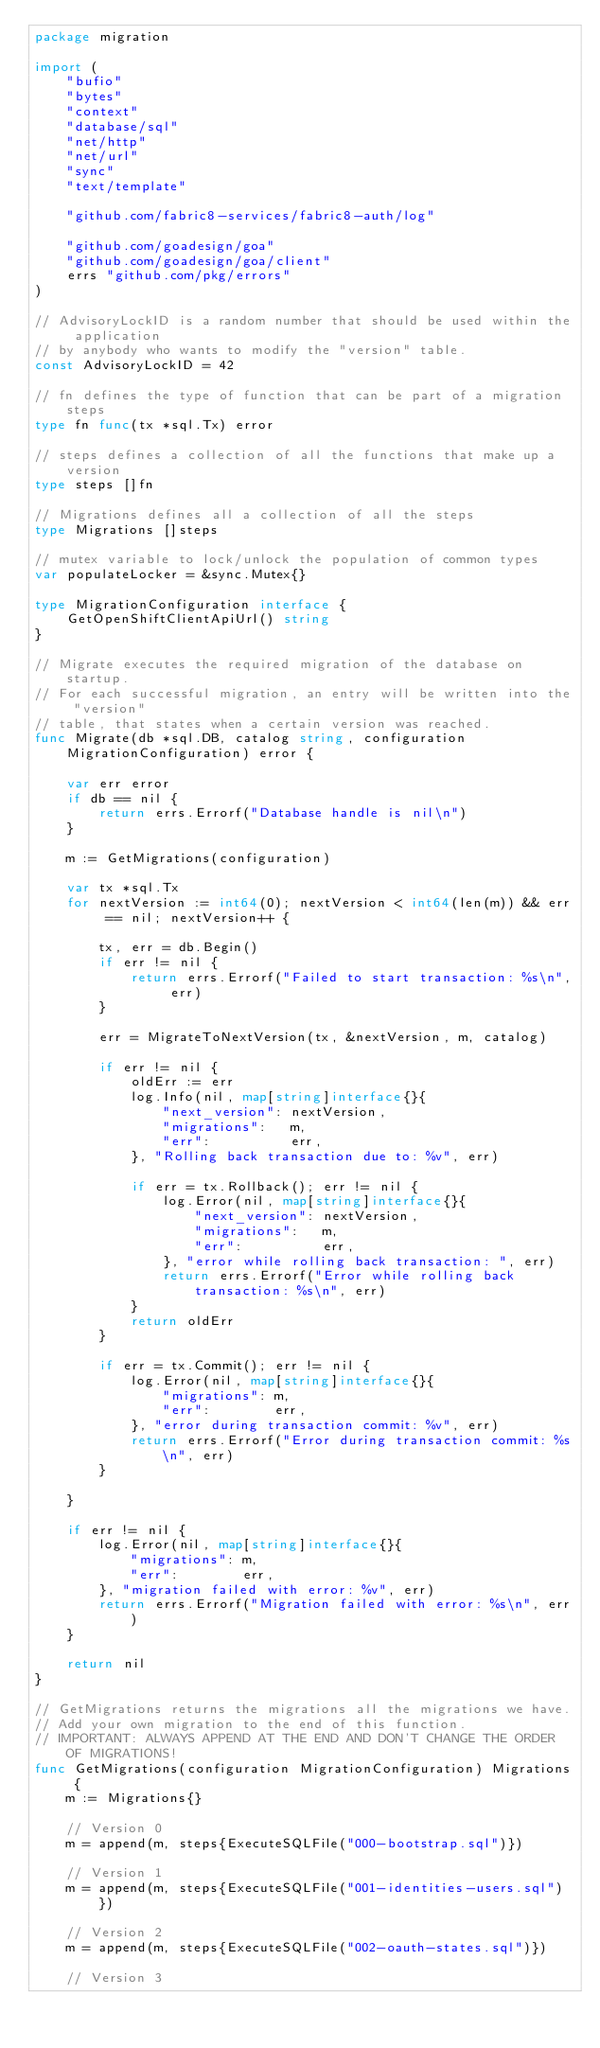Convert code to text. <code><loc_0><loc_0><loc_500><loc_500><_Go_>package migration

import (
	"bufio"
	"bytes"
	"context"
	"database/sql"
	"net/http"
	"net/url"
	"sync"
	"text/template"

	"github.com/fabric8-services/fabric8-auth/log"

	"github.com/goadesign/goa"
	"github.com/goadesign/goa/client"
	errs "github.com/pkg/errors"
)

// AdvisoryLockID is a random number that should be used within the application
// by anybody who wants to modify the "version" table.
const AdvisoryLockID = 42

// fn defines the type of function that can be part of a migration steps
type fn func(tx *sql.Tx) error

// steps defines a collection of all the functions that make up a version
type steps []fn

// Migrations defines all a collection of all the steps
type Migrations []steps

// mutex variable to lock/unlock the population of common types
var populateLocker = &sync.Mutex{}

type MigrationConfiguration interface {
	GetOpenShiftClientApiUrl() string
}

// Migrate executes the required migration of the database on startup.
// For each successful migration, an entry will be written into the "version"
// table, that states when a certain version was reached.
func Migrate(db *sql.DB, catalog string, configuration MigrationConfiguration) error {

	var err error
	if db == nil {
		return errs.Errorf("Database handle is nil\n")
	}

	m := GetMigrations(configuration)

	var tx *sql.Tx
	for nextVersion := int64(0); nextVersion < int64(len(m)) && err == nil; nextVersion++ {

		tx, err = db.Begin()
		if err != nil {
			return errs.Errorf("Failed to start transaction: %s\n", err)
		}

		err = MigrateToNextVersion(tx, &nextVersion, m, catalog)

		if err != nil {
			oldErr := err
			log.Info(nil, map[string]interface{}{
				"next_version": nextVersion,
				"migrations":   m,
				"err":          err,
			}, "Rolling back transaction due to: %v", err)

			if err = tx.Rollback(); err != nil {
				log.Error(nil, map[string]interface{}{
					"next_version": nextVersion,
					"migrations":   m,
					"err":          err,
				}, "error while rolling back transaction: ", err)
				return errs.Errorf("Error while rolling back transaction: %s\n", err)
			}
			return oldErr
		}

		if err = tx.Commit(); err != nil {
			log.Error(nil, map[string]interface{}{
				"migrations": m,
				"err":        err,
			}, "error during transaction commit: %v", err)
			return errs.Errorf("Error during transaction commit: %s\n", err)
		}

	}

	if err != nil {
		log.Error(nil, map[string]interface{}{
			"migrations": m,
			"err":        err,
		}, "migration failed with error: %v", err)
		return errs.Errorf("Migration failed with error: %s\n", err)
	}

	return nil
}

// GetMigrations returns the migrations all the migrations we have.
// Add your own migration to the end of this function.
// IMPORTANT: ALWAYS APPEND AT THE END AND DON'T CHANGE THE ORDER OF MIGRATIONS!
func GetMigrations(configuration MigrationConfiguration) Migrations {
	m := Migrations{}

	// Version 0
	m = append(m, steps{ExecuteSQLFile("000-bootstrap.sql")})

	// Version 1
	m = append(m, steps{ExecuteSQLFile("001-identities-users.sql")})

	// Version 2
	m = append(m, steps{ExecuteSQLFile("002-oauth-states.sql")})

	// Version 3</code> 